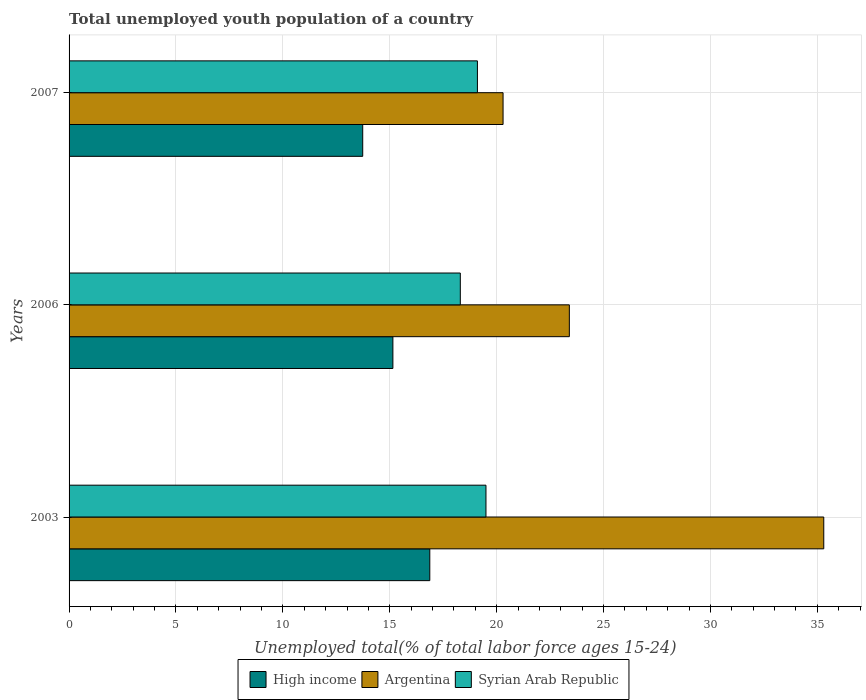How many different coloured bars are there?
Give a very brief answer. 3. How many groups of bars are there?
Offer a very short reply. 3. How many bars are there on the 1st tick from the top?
Make the answer very short. 3. How many bars are there on the 2nd tick from the bottom?
Your answer should be compact. 3. What is the label of the 1st group of bars from the top?
Provide a succinct answer. 2007. In how many cases, is the number of bars for a given year not equal to the number of legend labels?
Your answer should be compact. 0. What is the percentage of total unemployed youth population of a country in Syrian Arab Republic in 2007?
Keep it short and to the point. 19.1. Across all years, what is the maximum percentage of total unemployed youth population of a country in Syrian Arab Republic?
Provide a short and direct response. 19.5. Across all years, what is the minimum percentage of total unemployed youth population of a country in Argentina?
Make the answer very short. 20.3. In which year was the percentage of total unemployed youth population of a country in Syrian Arab Republic minimum?
Offer a very short reply. 2006. What is the total percentage of total unemployed youth population of a country in Syrian Arab Republic in the graph?
Your response must be concise. 56.9. What is the difference between the percentage of total unemployed youth population of a country in Argentina in 2006 and that in 2007?
Offer a very short reply. 3.1. What is the difference between the percentage of total unemployed youth population of a country in Syrian Arab Republic in 2006 and the percentage of total unemployed youth population of a country in High income in 2003?
Your answer should be compact. 1.43. What is the average percentage of total unemployed youth population of a country in High income per year?
Offer a very short reply. 15.25. In the year 2003, what is the difference between the percentage of total unemployed youth population of a country in Syrian Arab Republic and percentage of total unemployed youth population of a country in High income?
Give a very brief answer. 2.63. In how many years, is the percentage of total unemployed youth population of a country in Syrian Arab Republic greater than 24 %?
Keep it short and to the point. 0. What is the ratio of the percentage of total unemployed youth population of a country in Argentina in 2006 to that in 2007?
Your response must be concise. 1.15. Is the percentage of total unemployed youth population of a country in High income in 2003 less than that in 2006?
Provide a short and direct response. No. Is the difference between the percentage of total unemployed youth population of a country in Syrian Arab Republic in 2003 and 2006 greater than the difference between the percentage of total unemployed youth population of a country in High income in 2003 and 2006?
Your answer should be compact. No. What is the difference between the highest and the second highest percentage of total unemployed youth population of a country in Argentina?
Your answer should be very brief. 11.9. What is the difference between the highest and the lowest percentage of total unemployed youth population of a country in Argentina?
Keep it short and to the point. 15. In how many years, is the percentage of total unemployed youth population of a country in Argentina greater than the average percentage of total unemployed youth population of a country in Argentina taken over all years?
Give a very brief answer. 1. What does the 2nd bar from the bottom in 2006 represents?
Make the answer very short. Argentina. Is it the case that in every year, the sum of the percentage of total unemployed youth population of a country in High income and percentage of total unemployed youth population of a country in Syrian Arab Republic is greater than the percentage of total unemployed youth population of a country in Argentina?
Ensure brevity in your answer.  Yes. How many bars are there?
Give a very brief answer. 9. Are all the bars in the graph horizontal?
Offer a terse response. Yes. What is the difference between two consecutive major ticks on the X-axis?
Your answer should be very brief. 5. Are the values on the major ticks of X-axis written in scientific E-notation?
Make the answer very short. No. Does the graph contain any zero values?
Give a very brief answer. No. How many legend labels are there?
Your answer should be very brief. 3. What is the title of the graph?
Give a very brief answer. Total unemployed youth population of a country. Does "Netherlands" appear as one of the legend labels in the graph?
Your answer should be compact. No. What is the label or title of the X-axis?
Provide a short and direct response. Unemployed total(% of total labor force ages 15-24). What is the Unemployed total(% of total labor force ages 15-24) of High income in 2003?
Offer a terse response. 16.87. What is the Unemployed total(% of total labor force ages 15-24) of Argentina in 2003?
Your answer should be compact. 35.3. What is the Unemployed total(% of total labor force ages 15-24) in Syrian Arab Republic in 2003?
Make the answer very short. 19.5. What is the Unemployed total(% of total labor force ages 15-24) in High income in 2006?
Provide a succinct answer. 15.15. What is the Unemployed total(% of total labor force ages 15-24) in Argentina in 2006?
Your answer should be very brief. 23.4. What is the Unemployed total(% of total labor force ages 15-24) of Syrian Arab Republic in 2006?
Ensure brevity in your answer.  18.3. What is the Unemployed total(% of total labor force ages 15-24) of High income in 2007?
Your answer should be very brief. 13.74. What is the Unemployed total(% of total labor force ages 15-24) of Argentina in 2007?
Provide a succinct answer. 20.3. What is the Unemployed total(% of total labor force ages 15-24) of Syrian Arab Republic in 2007?
Give a very brief answer. 19.1. Across all years, what is the maximum Unemployed total(% of total labor force ages 15-24) of High income?
Offer a terse response. 16.87. Across all years, what is the maximum Unemployed total(% of total labor force ages 15-24) of Argentina?
Offer a terse response. 35.3. Across all years, what is the minimum Unemployed total(% of total labor force ages 15-24) of High income?
Keep it short and to the point. 13.74. Across all years, what is the minimum Unemployed total(% of total labor force ages 15-24) in Argentina?
Your answer should be very brief. 20.3. Across all years, what is the minimum Unemployed total(% of total labor force ages 15-24) of Syrian Arab Republic?
Offer a very short reply. 18.3. What is the total Unemployed total(% of total labor force ages 15-24) of High income in the graph?
Ensure brevity in your answer.  45.75. What is the total Unemployed total(% of total labor force ages 15-24) of Argentina in the graph?
Give a very brief answer. 79. What is the total Unemployed total(% of total labor force ages 15-24) of Syrian Arab Republic in the graph?
Provide a succinct answer. 56.9. What is the difference between the Unemployed total(% of total labor force ages 15-24) of High income in 2003 and that in 2006?
Give a very brief answer. 1.73. What is the difference between the Unemployed total(% of total labor force ages 15-24) of Argentina in 2003 and that in 2006?
Keep it short and to the point. 11.9. What is the difference between the Unemployed total(% of total labor force ages 15-24) of Syrian Arab Republic in 2003 and that in 2006?
Your response must be concise. 1.2. What is the difference between the Unemployed total(% of total labor force ages 15-24) of High income in 2003 and that in 2007?
Give a very brief answer. 3.14. What is the difference between the Unemployed total(% of total labor force ages 15-24) of High income in 2006 and that in 2007?
Your answer should be compact. 1.41. What is the difference between the Unemployed total(% of total labor force ages 15-24) in High income in 2003 and the Unemployed total(% of total labor force ages 15-24) in Argentina in 2006?
Provide a short and direct response. -6.53. What is the difference between the Unemployed total(% of total labor force ages 15-24) of High income in 2003 and the Unemployed total(% of total labor force ages 15-24) of Syrian Arab Republic in 2006?
Give a very brief answer. -1.43. What is the difference between the Unemployed total(% of total labor force ages 15-24) in Argentina in 2003 and the Unemployed total(% of total labor force ages 15-24) in Syrian Arab Republic in 2006?
Keep it short and to the point. 17. What is the difference between the Unemployed total(% of total labor force ages 15-24) in High income in 2003 and the Unemployed total(% of total labor force ages 15-24) in Argentina in 2007?
Make the answer very short. -3.43. What is the difference between the Unemployed total(% of total labor force ages 15-24) of High income in 2003 and the Unemployed total(% of total labor force ages 15-24) of Syrian Arab Republic in 2007?
Offer a very short reply. -2.23. What is the difference between the Unemployed total(% of total labor force ages 15-24) in Argentina in 2003 and the Unemployed total(% of total labor force ages 15-24) in Syrian Arab Republic in 2007?
Offer a very short reply. 16.2. What is the difference between the Unemployed total(% of total labor force ages 15-24) in High income in 2006 and the Unemployed total(% of total labor force ages 15-24) in Argentina in 2007?
Provide a succinct answer. -5.15. What is the difference between the Unemployed total(% of total labor force ages 15-24) of High income in 2006 and the Unemployed total(% of total labor force ages 15-24) of Syrian Arab Republic in 2007?
Make the answer very short. -3.95. What is the average Unemployed total(% of total labor force ages 15-24) of High income per year?
Ensure brevity in your answer.  15.25. What is the average Unemployed total(% of total labor force ages 15-24) in Argentina per year?
Give a very brief answer. 26.33. What is the average Unemployed total(% of total labor force ages 15-24) in Syrian Arab Republic per year?
Offer a terse response. 18.97. In the year 2003, what is the difference between the Unemployed total(% of total labor force ages 15-24) of High income and Unemployed total(% of total labor force ages 15-24) of Argentina?
Give a very brief answer. -18.43. In the year 2003, what is the difference between the Unemployed total(% of total labor force ages 15-24) in High income and Unemployed total(% of total labor force ages 15-24) in Syrian Arab Republic?
Keep it short and to the point. -2.63. In the year 2006, what is the difference between the Unemployed total(% of total labor force ages 15-24) in High income and Unemployed total(% of total labor force ages 15-24) in Argentina?
Your response must be concise. -8.25. In the year 2006, what is the difference between the Unemployed total(% of total labor force ages 15-24) in High income and Unemployed total(% of total labor force ages 15-24) in Syrian Arab Republic?
Offer a very short reply. -3.15. In the year 2007, what is the difference between the Unemployed total(% of total labor force ages 15-24) in High income and Unemployed total(% of total labor force ages 15-24) in Argentina?
Make the answer very short. -6.56. In the year 2007, what is the difference between the Unemployed total(% of total labor force ages 15-24) of High income and Unemployed total(% of total labor force ages 15-24) of Syrian Arab Republic?
Make the answer very short. -5.36. What is the ratio of the Unemployed total(% of total labor force ages 15-24) in High income in 2003 to that in 2006?
Ensure brevity in your answer.  1.11. What is the ratio of the Unemployed total(% of total labor force ages 15-24) of Argentina in 2003 to that in 2006?
Provide a succinct answer. 1.51. What is the ratio of the Unemployed total(% of total labor force ages 15-24) of Syrian Arab Republic in 2003 to that in 2006?
Your answer should be compact. 1.07. What is the ratio of the Unemployed total(% of total labor force ages 15-24) in High income in 2003 to that in 2007?
Ensure brevity in your answer.  1.23. What is the ratio of the Unemployed total(% of total labor force ages 15-24) in Argentina in 2003 to that in 2007?
Your answer should be compact. 1.74. What is the ratio of the Unemployed total(% of total labor force ages 15-24) of Syrian Arab Republic in 2003 to that in 2007?
Your answer should be very brief. 1.02. What is the ratio of the Unemployed total(% of total labor force ages 15-24) in High income in 2006 to that in 2007?
Your answer should be very brief. 1.1. What is the ratio of the Unemployed total(% of total labor force ages 15-24) in Argentina in 2006 to that in 2007?
Your answer should be compact. 1.15. What is the ratio of the Unemployed total(% of total labor force ages 15-24) of Syrian Arab Republic in 2006 to that in 2007?
Make the answer very short. 0.96. What is the difference between the highest and the second highest Unemployed total(% of total labor force ages 15-24) of High income?
Your response must be concise. 1.73. What is the difference between the highest and the lowest Unemployed total(% of total labor force ages 15-24) in High income?
Your answer should be very brief. 3.14. What is the difference between the highest and the lowest Unemployed total(% of total labor force ages 15-24) of Syrian Arab Republic?
Give a very brief answer. 1.2. 